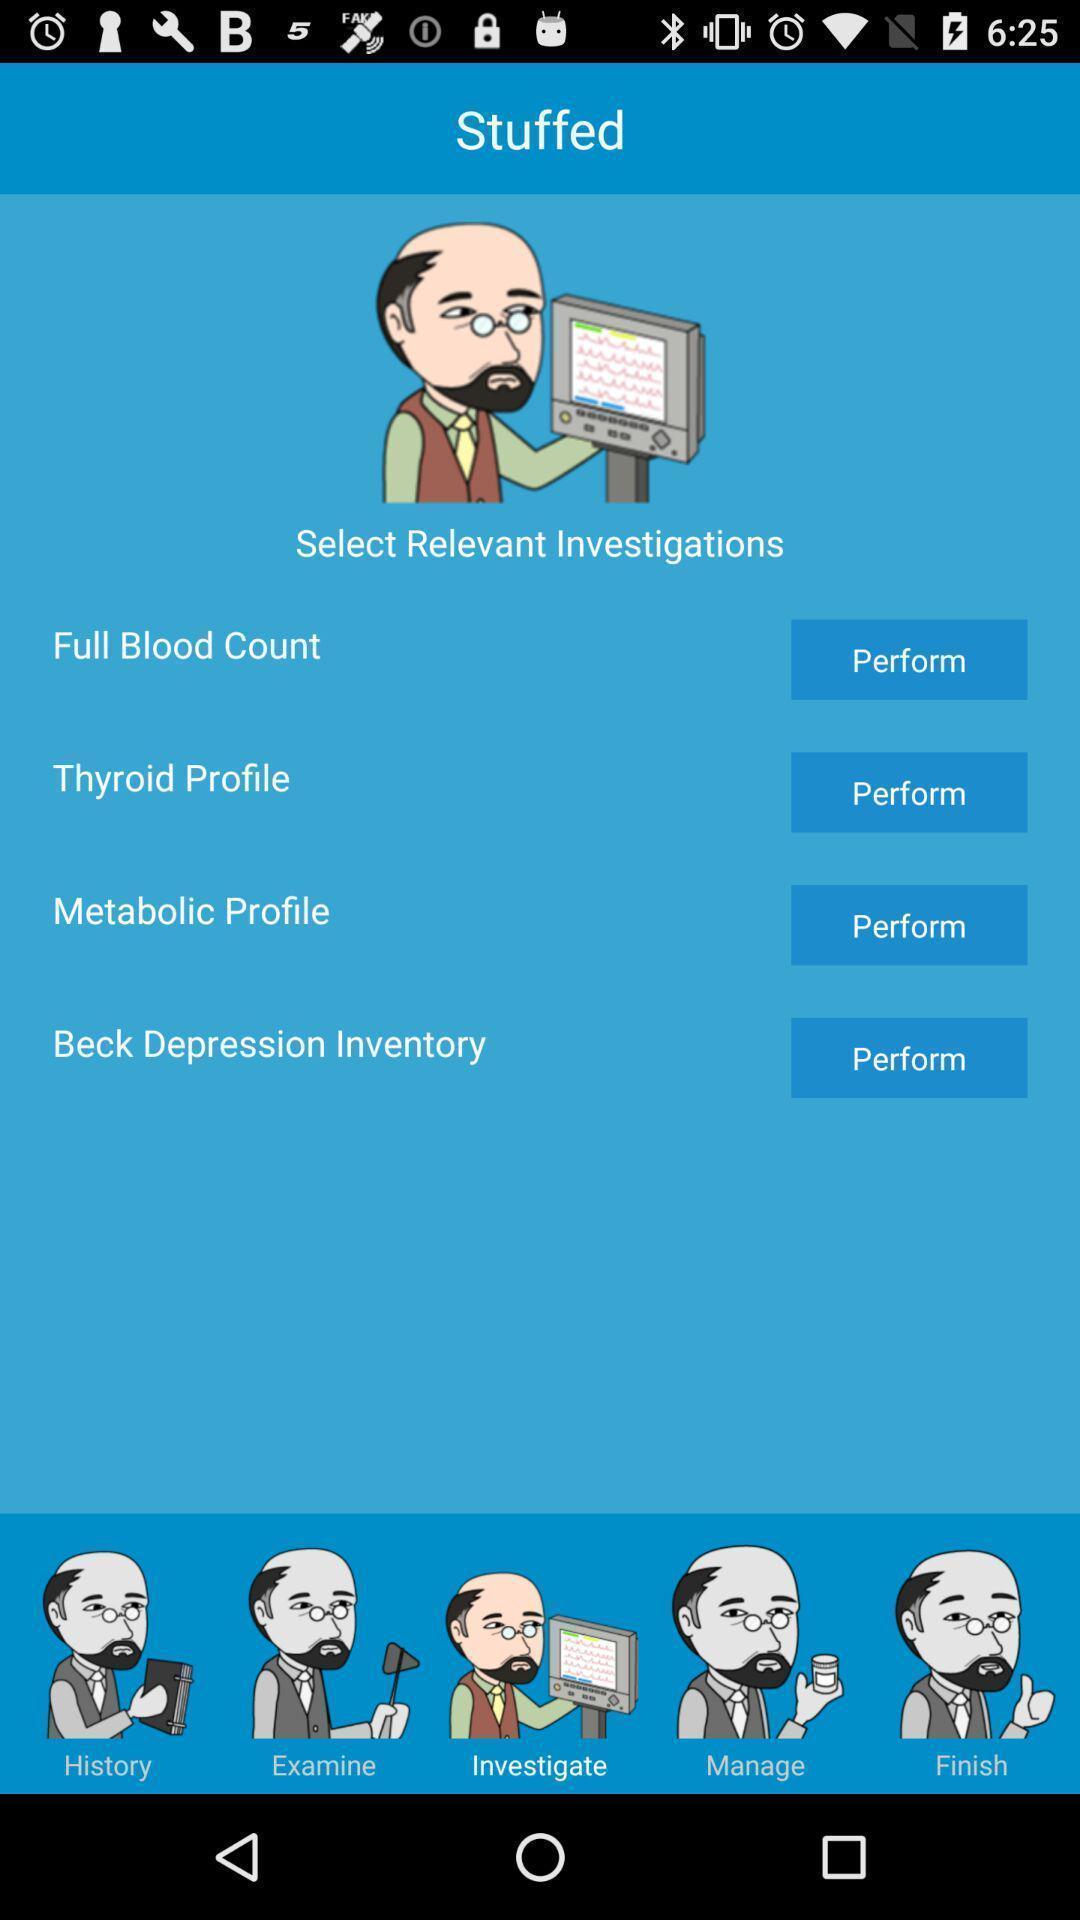Give me a narrative description of this picture. Page displaying the list to select relevant investigations. 